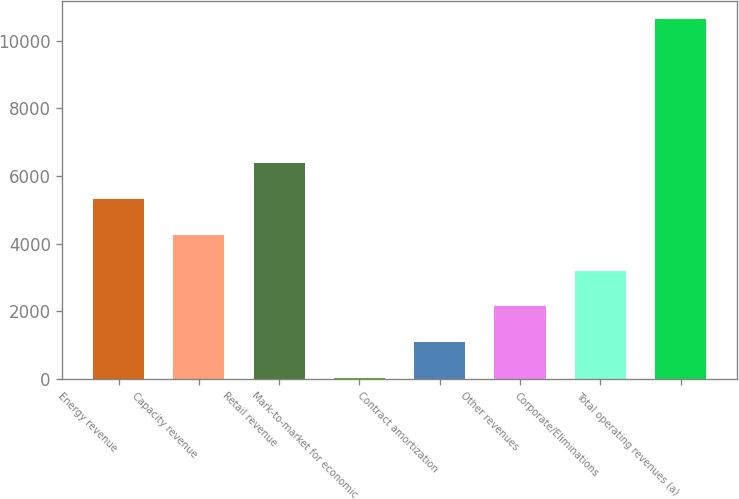Convert chart. <chart><loc_0><loc_0><loc_500><loc_500><bar_chart><fcel>Energy revenue<fcel>Capacity revenue<fcel>Retail revenue<fcel>Mark-to-market for economic<fcel>Contract amortization<fcel>Other revenues<fcel>Corporate/Eliminations<fcel>Total operating revenues (a)<nl><fcel>5325<fcel>4264.2<fcel>6385.8<fcel>21<fcel>1081.8<fcel>2142.6<fcel>3203.4<fcel>10629<nl></chart> 